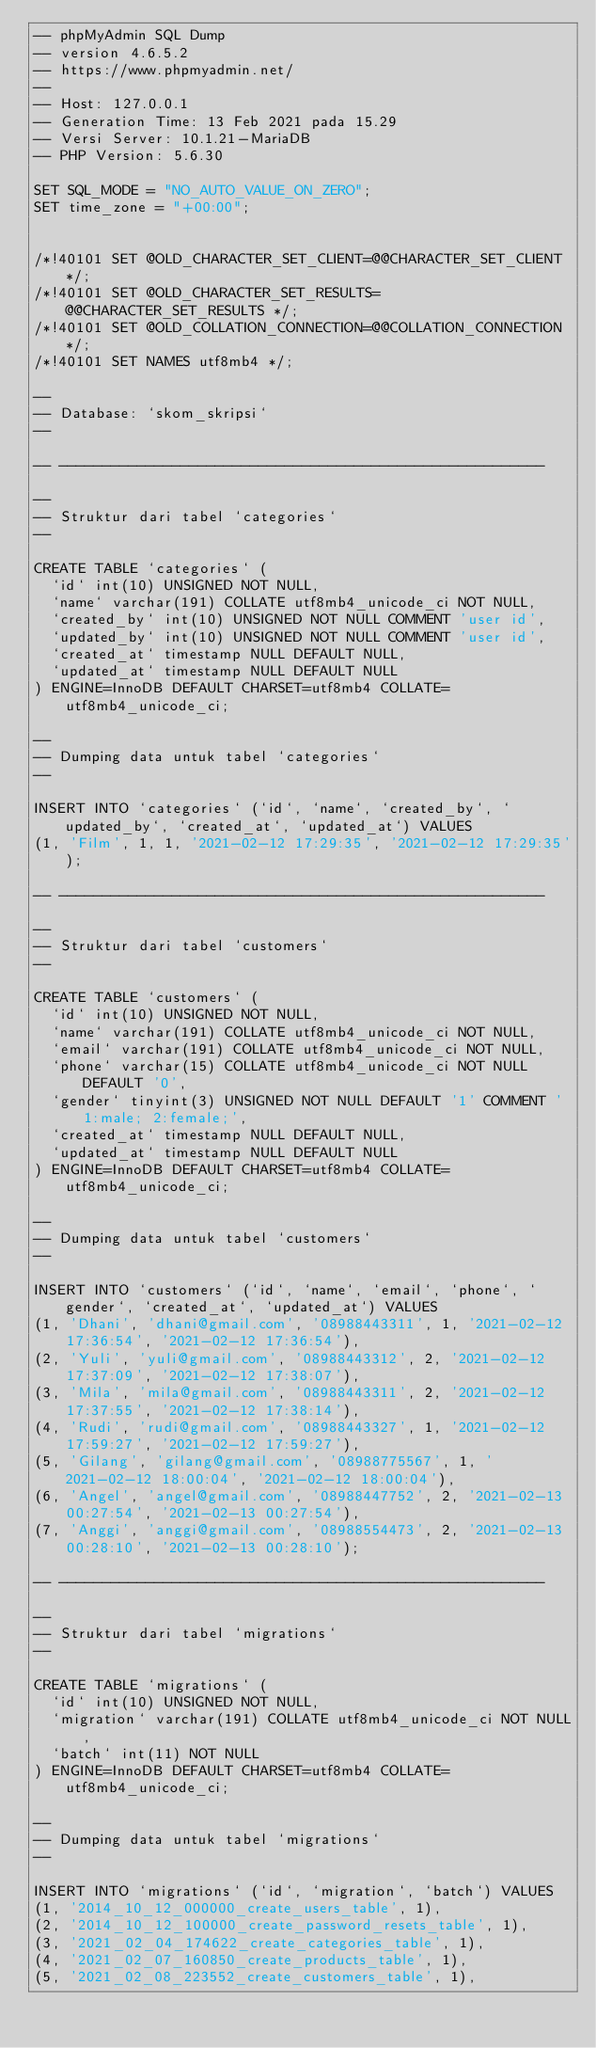Convert code to text. <code><loc_0><loc_0><loc_500><loc_500><_SQL_>-- phpMyAdmin SQL Dump
-- version 4.6.5.2
-- https://www.phpmyadmin.net/
--
-- Host: 127.0.0.1
-- Generation Time: 13 Feb 2021 pada 15.29
-- Versi Server: 10.1.21-MariaDB
-- PHP Version: 5.6.30

SET SQL_MODE = "NO_AUTO_VALUE_ON_ZERO";
SET time_zone = "+00:00";


/*!40101 SET @OLD_CHARACTER_SET_CLIENT=@@CHARACTER_SET_CLIENT */;
/*!40101 SET @OLD_CHARACTER_SET_RESULTS=@@CHARACTER_SET_RESULTS */;
/*!40101 SET @OLD_COLLATION_CONNECTION=@@COLLATION_CONNECTION */;
/*!40101 SET NAMES utf8mb4 */;

--
-- Database: `skom_skripsi`
--

-- --------------------------------------------------------

--
-- Struktur dari tabel `categories`
--

CREATE TABLE `categories` (
  `id` int(10) UNSIGNED NOT NULL,
  `name` varchar(191) COLLATE utf8mb4_unicode_ci NOT NULL,
  `created_by` int(10) UNSIGNED NOT NULL COMMENT 'user id',
  `updated_by` int(10) UNSIGNED NOT NULL COMMENT 'user id',
  `created_at` timestamp NULL DEFAULT NULL,
  `updated_at` timestamp NULL DEFAULT NULL
) ENGINE=InnoDB DEFAULT CHARSET=utf8mb4 COLLATE=utf8mb4_unicode_ci;

--
-- Dumping data untuk tabel `categories`
--

INSERT INTO `categories` (`id`, `name`, `created_by`, `updated_by`, `created_at`, `updated_at`) VALUES
(1, 'Film', 1, 1, '2021-02-12 17:29:35', '2021-02-12 17:29:35');

-- --------------------------------------------------------

--
-- Struktur dari tabel `customers`
--

CREATE TABLE `customers` (
  `id` int(10) UNSIGNED NOT NULL,
  `name` varchar(191) COLLATE utf8mb4_unicode_ci NOT NULL,
  `email` varchar(191) COLLATE utf8mb4_unicode_ci NOT NULL,
  `phone` varchar(15) COLLATE utf8mb4_unicode_ci NOT NULL DEFAULT '0',
  `gender` tinyint(3) UNSIGNED NOT NULL DEFAULT '1' COMMENT '1:male; 2:female;',
  `created_at` timestamp NULL DEFAULT NULL,
  `updated_at` timestamp NULL DEFAULT NULL
) ENGINE=InnoDB DEFAULT CHARSET=utf8mb4 COLLATE=utf8mb4_unicode_ci;

--
-- Dumping data untuk tabel `customers`
--

INSERT INTO `customers` (`id`, `name`, `email`, `phone`, `gender`, `created_at`, `updated_at`) VALUES
(1, 'Dhani', 'dhani@gmail.com', '08988443311', 1, '2021-02-12 17:36:54', '2021-02-12 17:36:54'),
(2, 'Yuli', 'yuli@gmail.com', '08988443312', 2, '2021-02-12 17:37:09', '2021-02-12 17:38:07'),
(3, 'Mila', 'mila@gmail.com', '08988443311', 2, '2021-02-12 17:37:55', '2021-02-12 17:38:14'),
(4, 'Rudi', 'rudi@gmail.com', '08988443327', 1, '2021-02-12 17:59:27', '2021-02-12 17:59:27'),
(5, 'Gilang', 'gilang@gmail.com', '08988775567', 1, '2021-02-12 18:00:04', '2021-02-12 18:00:04'),
(6, 'Angel', 'angel@gmail.com', '08988447752', 2, '2021-02-13 00:27:54', '2021-02-13 00:27:54'),
(7, 'Anggi', 'anggi@gmail.com', '08988554473', 2, '2021-02-13 00:28:10', '2021-02-13 00:28:10');

-- --------------------------------------------------------

--
-- Struktur dari tabel `migrations`
--

CREATE TABLE `migrations` (
  `id` int(10) UNSIGNED NOT NULL,
  `migration` varchar(191) COLLATE utf8mb4_unicode_ci NOT NULL,
  `batch` int(11) NOT NULL
) ENGINE=InnoDB DEFAULT CHARSET=utf8mb4 COLLATE=utf8mb4_unicode_ci;

--
-- Dumping data untuk tabel `migrations`
--

INSERT INTO `migrations` (`id`, `migration`, `batch`) VALUES
(1, '2014_10_12_000000_create_users_table', 1),
(2, '2014_10_12_100000_create_password_resets_table', 1),
(3, '2021_02_04_174622_create_categories_table', 1),
(4, '2021_02_07_160850_create_products_table', 1),
(5, '2021_02_08_223552_create_customers_table', 1),</code> 